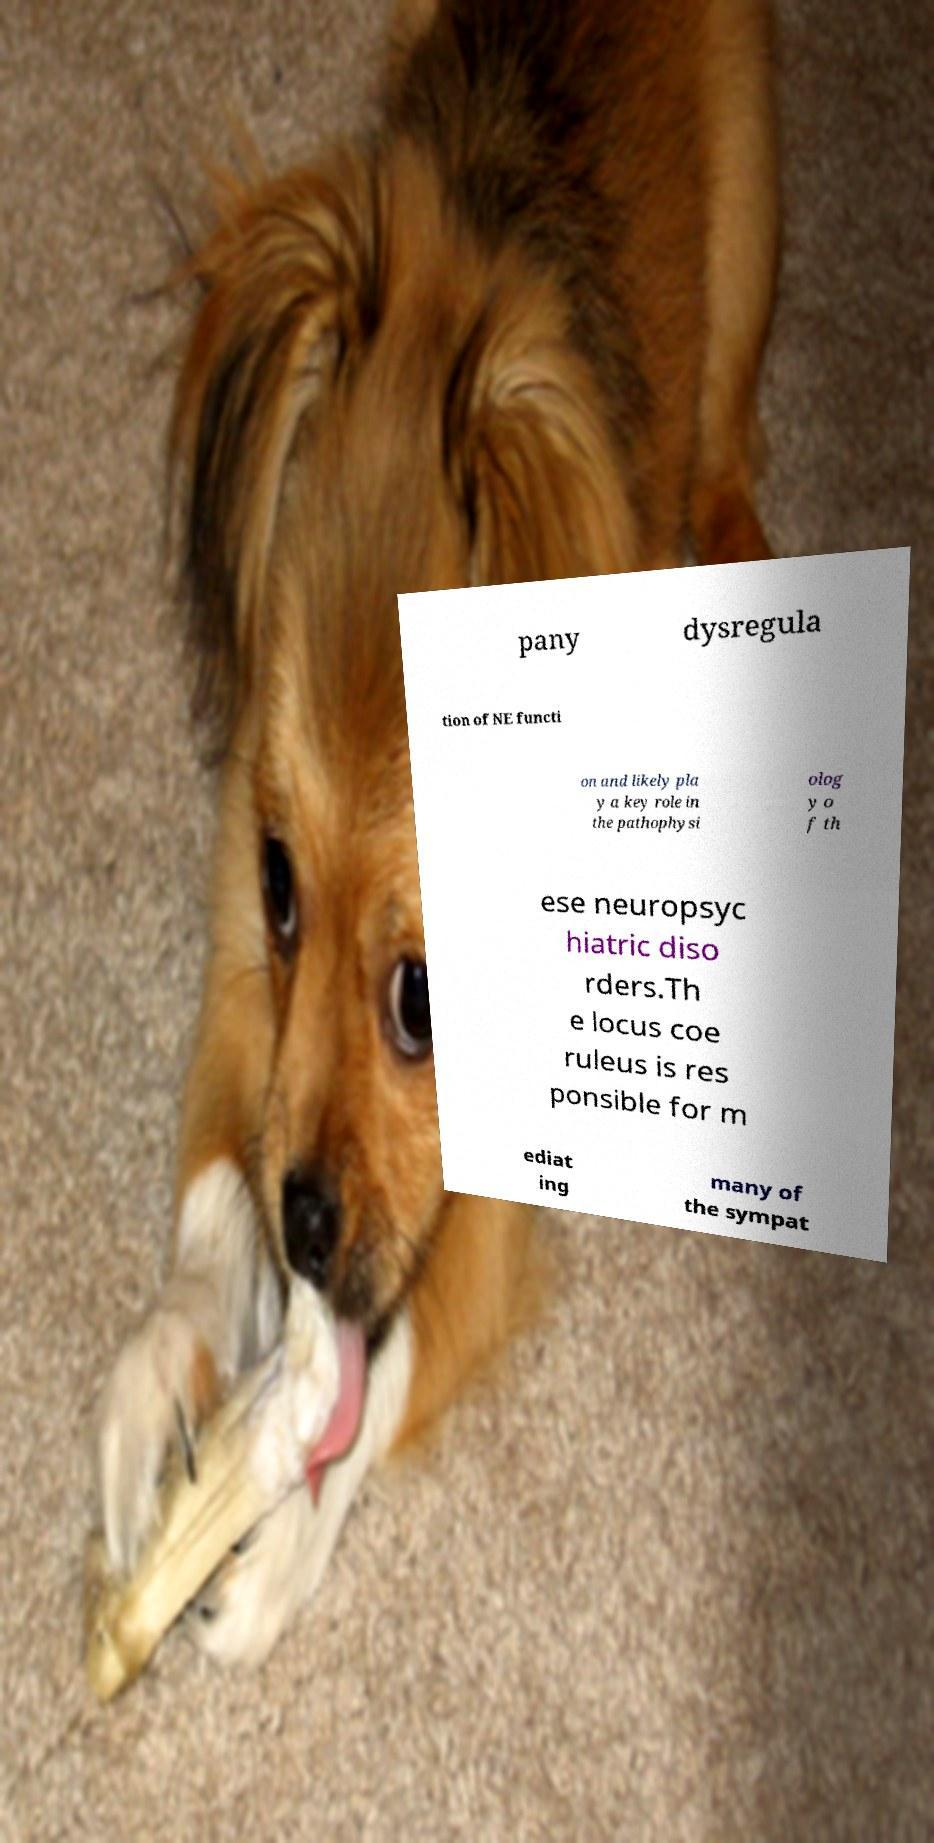Please identify and transcribe the text found in this image. pany dysregula tion of NE functi on and likely pla y a key role in the pathophysi olog y o f th ese neuropsyc hiatric diso rders.Th e locus coe ruleus is res ponsible for m ediat ing many of the sympat 